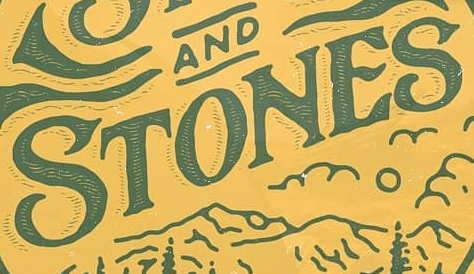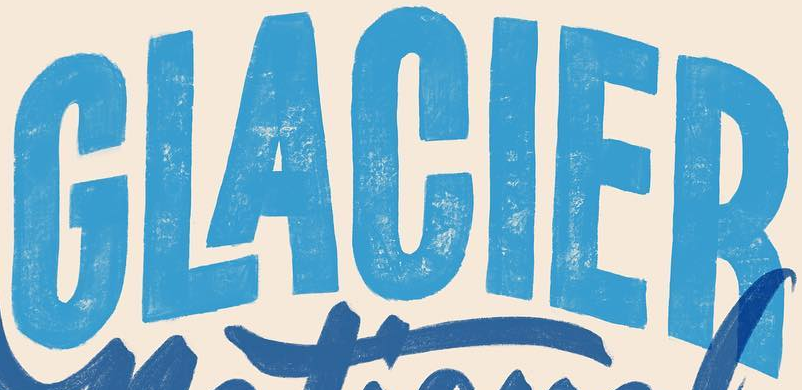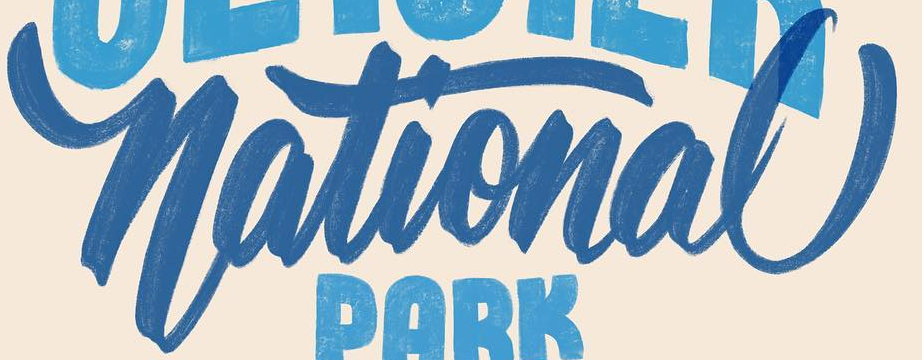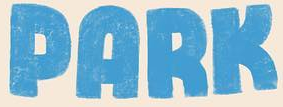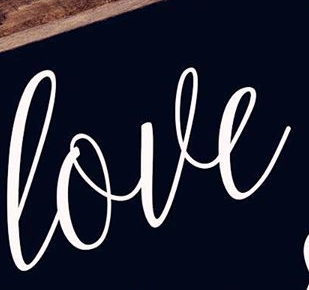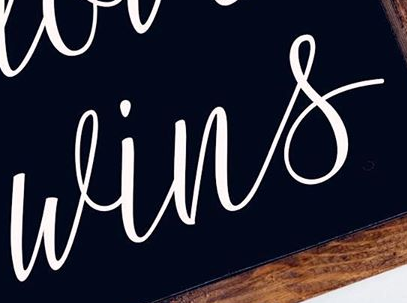Read the text content from these images in order, separated by a semicolon. STONES; GLACIER; National; PARK; love; wins 